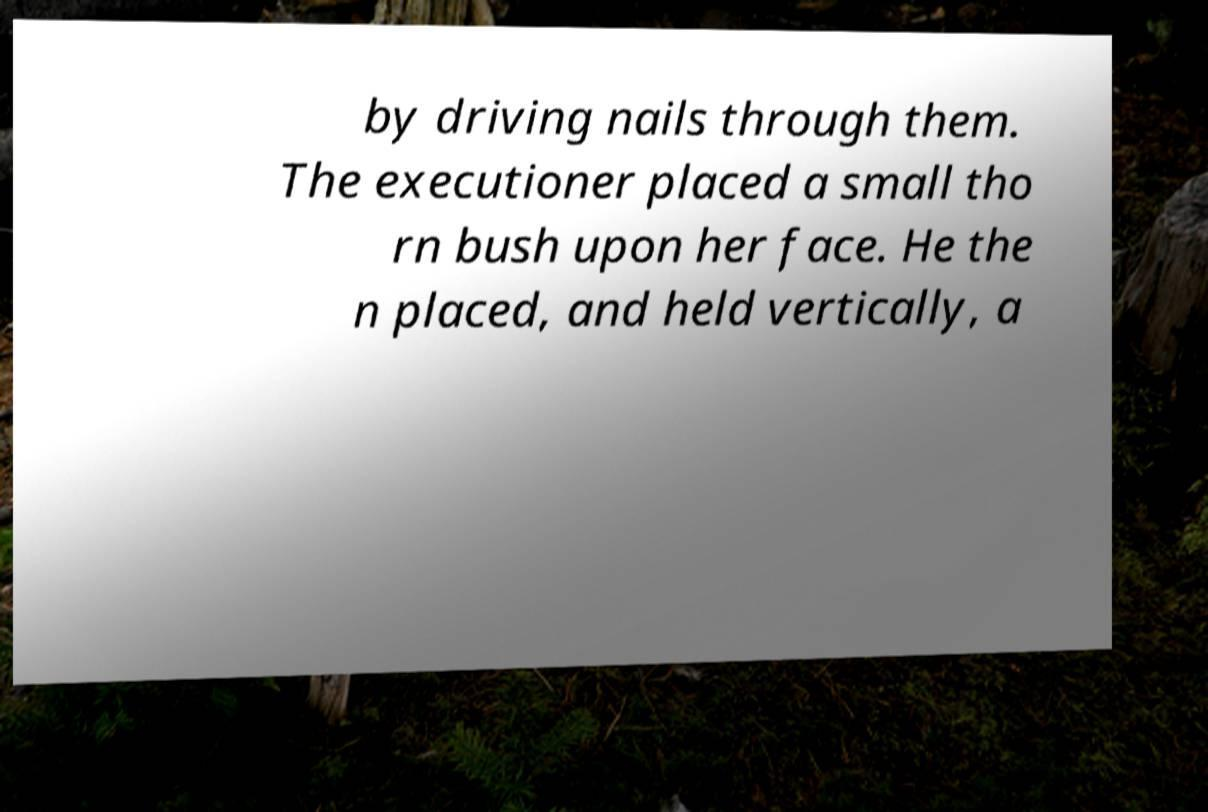Please identify and transcribe the text found in this image. by driving nails through them. The executioner placed a small tho rn bush upon her face. He the n placed, and held vertically, a 